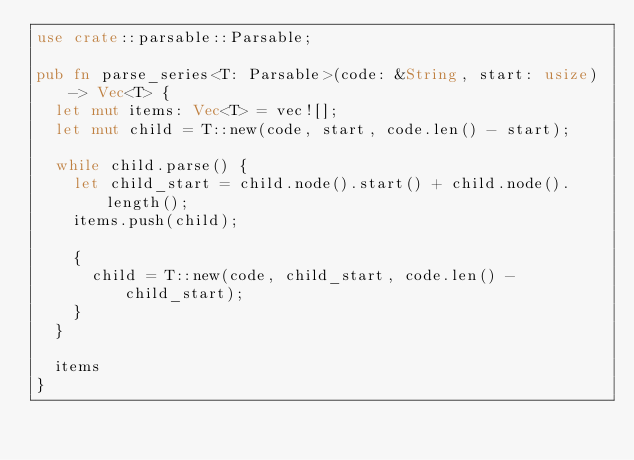Convert code to text. <code><loc_0><loc_0><loc_500><loc_500><_Rust_>use crate::parsable::Parsable;

pub fn parse_series<T: Parsable>(code: &String, start: usize) -> Vec<T> {
  let mut items: Vec<T> = vec![];
  let mut child = T::new(code, start, code.len() - start);

  while child.parse() {
    let child_start = child.node().start() + child.node().length();
    items.push(child);

    {
      child = T::new(code, child_start, code.len() - child_start);
    }
  }

  items
}
</code> 